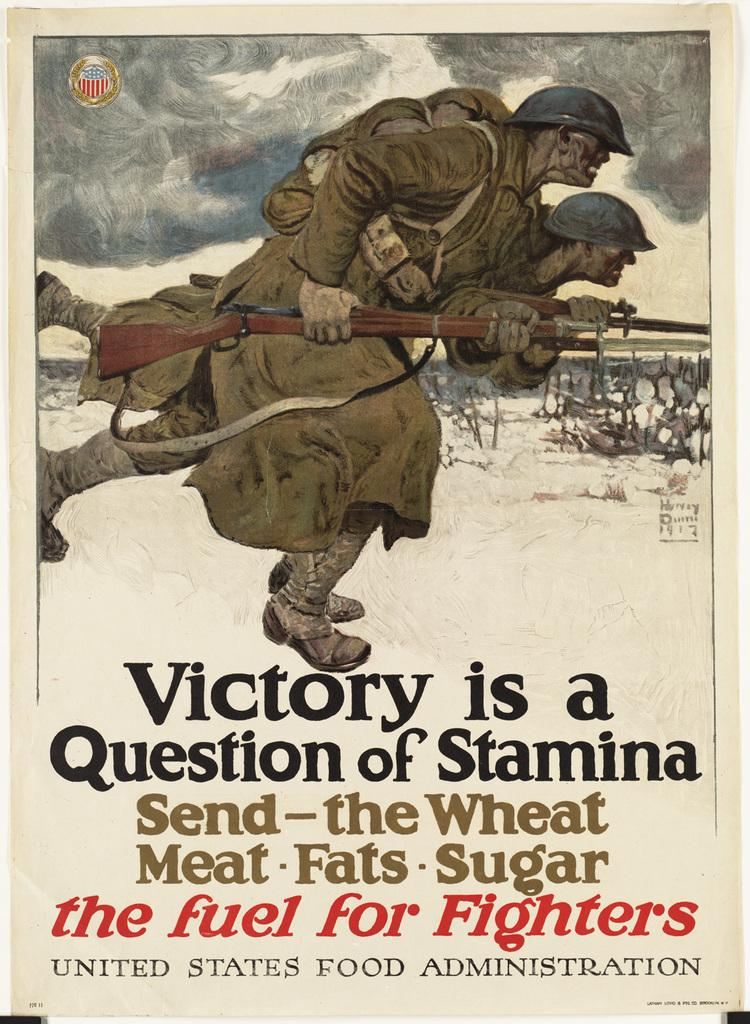Provide a one-sentence caption for the provided image. poster with soliders on it and says Victory is a Question of Stamina Send- the Wheat Meat Fats Sugar the fuel for Fighters. 